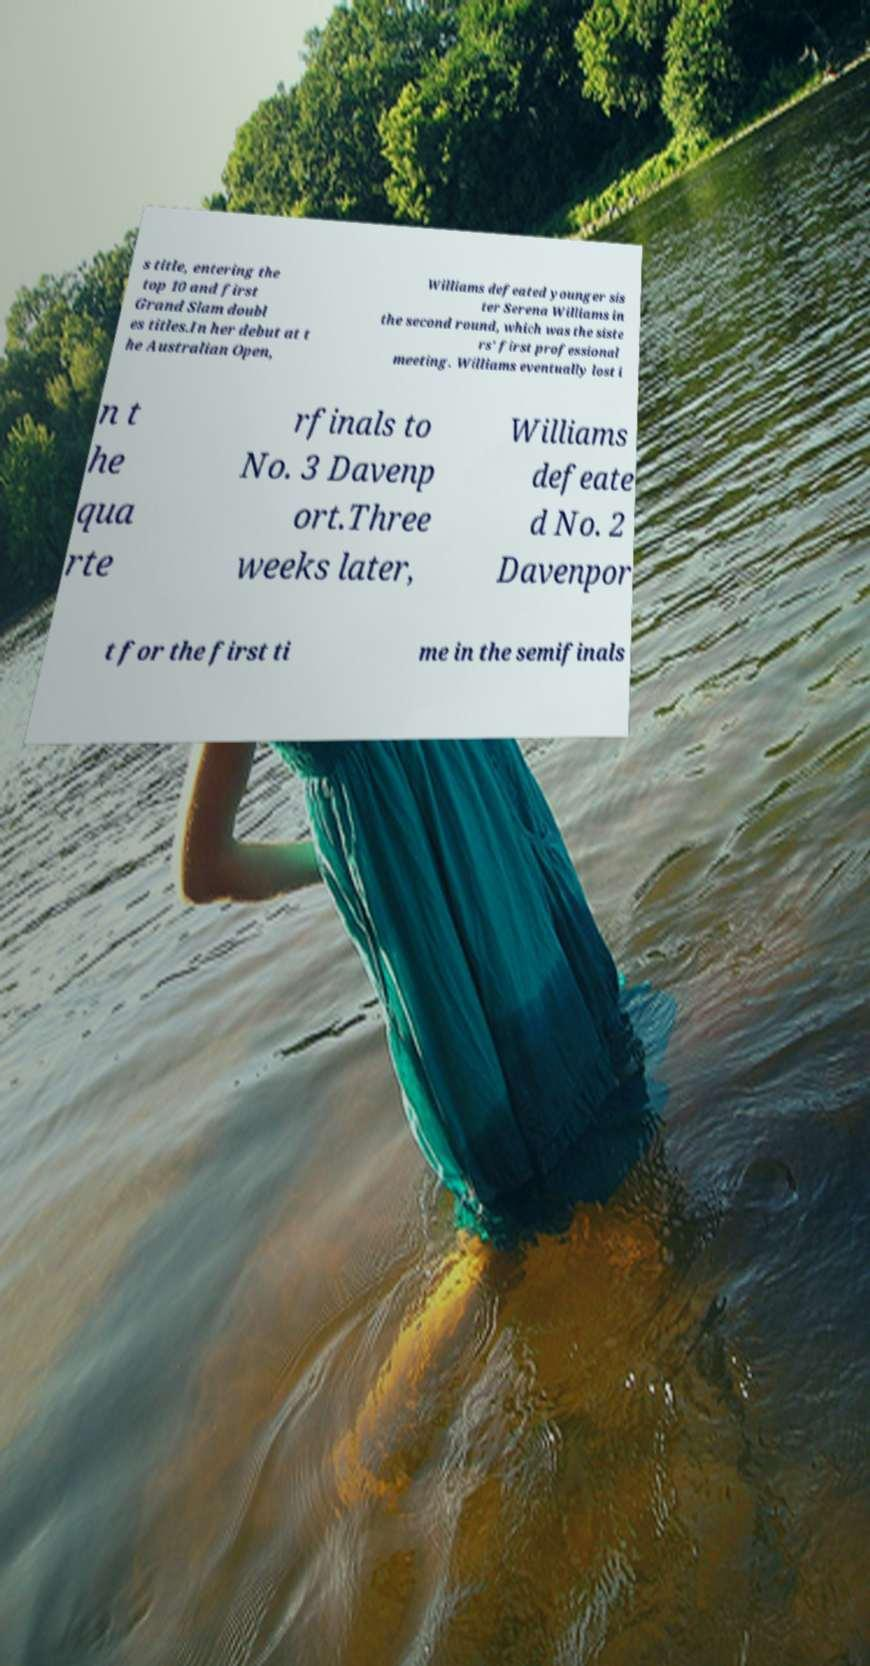Could you assist in decoding the text presented in this image and type it out clearly? s title, entering the top 10 and first Grand Slam doubl es titles.In her debut at t he Australian Open, Williams defeated younger sis ter Serena Williams in the second round, which was the siste rs' first professional meeting. Williams eventually lost i n t he qua rte rfinals to No. 3 Davenp ort.Three weeks later, Williams defeate d No. 2 Davenpor t for the first ti me in the semifinals 